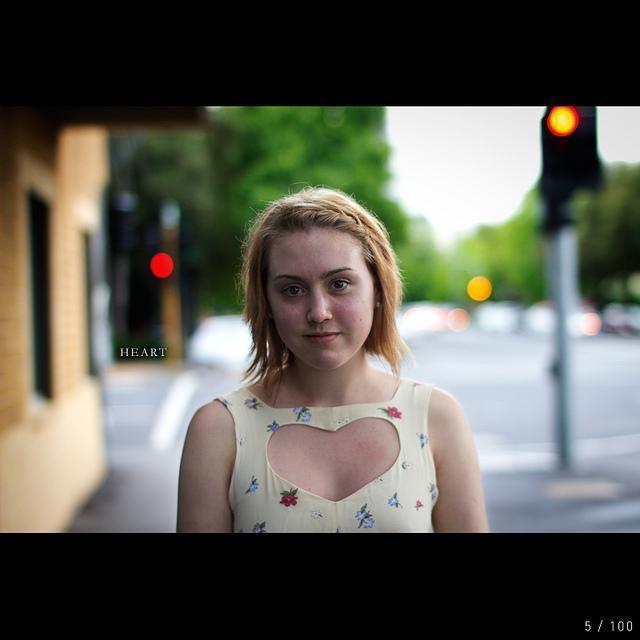What age group is this person in?
Choose the right answer and clarify with the format: 'Answer: answer
Rationale: rationale.'
Options: 5-13, 35-50, 55-70, 18-30. Answer: 18-30.
Rationale: The group is a young adult. 